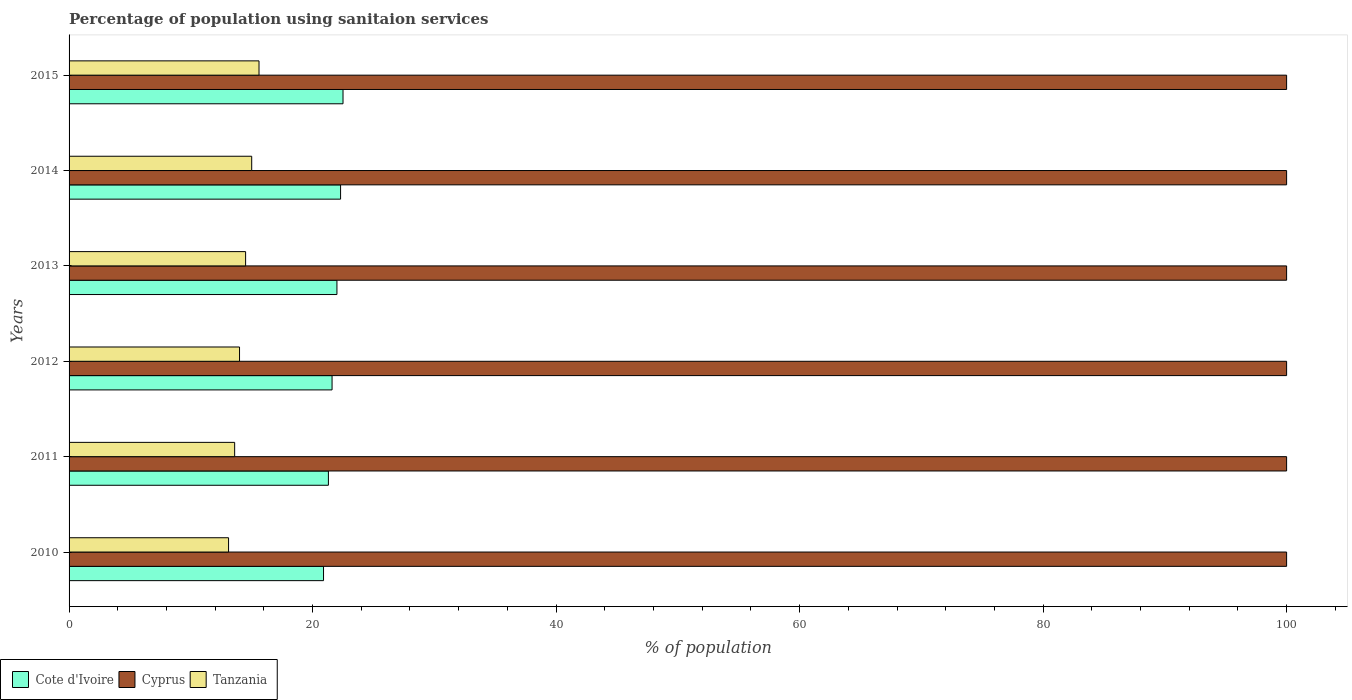How many bars are there on the 5th tick from the bottom?
Ensure brevity in your answer.  3. In how many cases, is the number of bars for a given year not equal to the number of legend labels?
Offer a very short reply. 0. What is the percentage of population using sanitaion services in Cyprus in 2010?
Give a very brief answer. 100. Across all years, what is the maximum percentage of population using sanitaion services in Cyprus?
Your response must be concise. 100. Across all years, what is the minimum percentage of population using sanitaion services in Cote d'Ivoire?
Offer a very short reply. 20.9. In which year was the percentage of population using sanitaion services in Tanzania minimum?
Make the answer very short. 2010. What is the total percentage of population using sanitaion services in Cote d'Ivoire in the graph?
Your response must be concise. 130.6. What is the difference between the percentage of population using sanitaion services in Tanzania in 2010 and that in 2013?
Offer a terse response. -1.4. What is the average percentage of population using sanitaion services in Cyprus per year?
Make the answer very short. 100. In the year 2015, what is the difference between the percentage of population using sanitaion services in Cyprus and percentage of population using sanitaion services in Cote d'Ivoire?
Give a very brief answer. 77.5. In how many years, is the percentage of population using sanitaion services in Tanzania greater than 72 %?
Your response must be concise. 0. What is the difference between the highest and the second highest percentage of population using sanitaion services in Cyprus?
Give a very brief answer. 0. What is the difference between the highest and the lowest percentage of population using sanitaion services in Cote d'Ivoire?
Ensure brevity in your answer.  1.6. What does the 1st bar from the top in 2015 represents?
Provide a short and direct response. Tanzania. What does the 2nd bar from the bottom in 2014 represents?
Provide a short and direct response. Cyprus. Is it the case that in every year, the sum of the percentage of population using sanitaion services in Cote d'Ivoire and percentage of population using sanitaion services in Tanzania is greater than the percentage of population using sanitaion services in Cyprus?
Keep it short and to the point. No. How many bars are there?
Provide a short and direct response. 18. Are all the bars in the graph horizontal?
Offer a very short reply. Yes. What is the difference between two consecutive major ticks on the X-axis?
Your answer should be compact. 20. What is the title of the graph?
Offer a terse response. Percentage of population using sanitaion services. Does "Guam" appear as one of the legend labels in the graph?
Provide a short and direct response. No. What is the label or title of the X-axis?
Provide a succinct answer. % of population. What is the label or title of the Y-axis?
Provide a short and direct response. Years. What is the % of population of Cote d'Ivoire in 2010?
Your response must be concise. 20.9. What is the % of population in Cyprus in 2010?
Your answer should be compact. 100. What is the % of population of Cote d'Ivoire in 2011?
Provide a succinct answer. 21.3. What is the % of population of Tanzania in 2011?
Give a very brief answer. 13.6. What is the % of population in Cote d'Ivoire in 2012?
Offer a very short reply. 21.6. What is the % of population of Cyprus in 2012?
Keep it short and to the point. 100. What is the % of population in Tanzania in 2012?
Ensure brevity in your answer.  14. What is the % of population of Cote d'Ivoire in 2013?
Provide a short and direct response. 22. What is the % of population of Cyprus in 2013?
Ensure brevity in your answer.  100. What is the % of population of Cote d'Ivoire in 2014?
Offer a terse response. 22.3. What is the % of population in Cyprus in 2014?
Your answer should be very brief. 100. What is the % of population in Cyprus in 2015?
Your answer should be compact. 100. Across all years, what is the maximum % of population of Cote d'Ivoire?
Give a very brief answer. 22.5. Across all years, what is the maximum % of population in Cyprus?
Give a very brief answer. 100. Across all years, what is the minimum % of population of Cote d'Ivoire?
Your answer should be very brief. 20.9. Across all years, what is the minimum % of population of Tanzania?
Give a very brief answer. 13.1. What is the total % of population in Cote d'Ivoire in the graph?
Your answer should be very brief. 130.6. What is the total % of population in Cyprus in the graph?
Give a very brief answer. 600. What is the total % of population of Tanzania in the graph?
Your response must be concise. 85.8. What is the difference between the % of population in Tanzania in 2010 and that in 2011?
Provide a short and direct response. -0.5. What is the difference between the % of population in Cyprus in 2010 and that in 2012?
Your response must be concise. 0. What is the difference between the % of population in Cote d'Ivoire in 2010 and that in 2013?
Your answer should be compact. -1.1. What is the difference between the % of population of Cyprus in 2010 and that in 2013?
Your response must be concise. 0. What is the difference between the % of population in Cyprus in 2010 and that in 2014?
Your answer should be compact. 0. What is the difference between the % of population in Cote d'Ivoire in 2010 and that in 2015?
Your answer should be compact. -1.6. What is the difference between the % of population in Cote d'Ivoire in 2012 and that in 2013?
Offer a very short reply. -0.4. What is the difference between the % of population in Cyprus in 2012 and that in 2013?
Give a very brief answer. 0. What is the difference between the % of population of Tanzania in 2012 and that in 2015?
Your response must be concise. -1.6. What is the difference between the % of population in Cyprus in 2013 and that in 2014?
Your answer should be compact. 0. What is the difference between the % of population of Tanzania in 2013 and that in 2015?
Keep it short and to the point. -1.1. What is the difference between the % of population of Cote d'Ivoire in 2014 and that in 2015?
Your response must be concise. -0.2. What is the difference between the % of population in Cyprus in 2014 and that in 2015?
Offer a terse response. 0. What is the difference between the % of population in Cote d'Ivoire in 2010 and the % of population in Cyprus in 2011?
Provide a short and direct response. -79.1. What is the difference between the % of population of Cyprus in 2010 and the % of population of Tanzania in 2011?
Keep it short and to the point. 86.4. What is the difference between the % of population of Cote d'Ivoire in 2010 and the % of population of Cyprus in 2012?
Provide a short and direct response. -79.1. What is the difference between the % of population of Cote d'Ivoire in 2010 and the % of population of Tanzania in 2012?
Ensure brevity in your answer.  6.9. What is the difference between the % of population of Cote d'Ivoire in 2010 and the % of population of Cyprus in 2013?
Make the answer very short. -79.1. What is the difference between the % of population in Cyprus in 2010 and the % of population in Tanzania in 2013?
Offer a very short reply. 85.5. What is the difference between the % of population of Cote d'Ivoire in 2010 and the % of population of Cyprus in 2014?
Provide a short and direct response. -79.1. What is the difference between the % of population in Cote d'Ivoire in 2010 and the % of population in Tanzania in 2014?
Make the answer very short. 5.9. What is the difference between the % of population of Cyprus in 2010 and the % of population of Tanzania in 2014?
Ensure brevity in your answer.  85. What is the difference between the % of population in Cote d'Ivoire in 2010 and the % of population in Cyprus in 2015?
Give a very brief answer. -79.1. What is the difference between the % of population in Cyprus in 2010 and the % of population in Tanzania in 2015?
Provide a short and direct response. 84.4. What is the difference between the % of population in Cote d'Ivoire in 2011 and the % of population in Cyprus in 2012?
Offer a very short reply. -78.7. What is the difference between the % of population of Cyprus in 2011 and the % of population of Tanzania in 2012?
Make the answer very short. 86. What is the difference between the % of population in Cote d'Ivoire in 2011 and the % of population in Cyprus in 2013?
Give a very brief answer. -78.7. What is the difference between the % of population of Cote d'Ivoire in 2011 and the % of population of Tanzania in 2013?
Provide a succinct answer. 6.8. What is the difference between the % of population of Cyprus in 2011 and the % of population of Tanzania in 2013?
Your response must be concise. 85.5. What is the difference between the % of population in Cote d'Ivoire in 2011 and the % of population in Cyprus in 2014?
Provide a short and direct response. -78.7. What is the difference between the % of population of Cyprus in 2011 and the % of population of Tanzania in 2014?
Provide a succinct answer. 85. What is the difference between the % of population of Cote d'Ivoire in 2011 and the % of population of Cyprus in 2015?
Your response must be concise. -78.7. What is the difference between the % of population in Cote d'Ivoire in 2011 and the % of population in Tanzania in 2015?
Your answer should be very brief. 5.7. What is the difference between the % of population of Cyprus in 2011 and the % of population of Tanzania in 2015?
Provide a short and direct response. 84.4. What is the difference between the % of population in Cote d'Ivoire in 2012 and the % of population in Cyprus in 2013?
Your answer should be very brief. -78.4. What is the difference between the % of population in Cote d'Ivoire in 2012 and the % of population in Tanzania in 2013?
Give a very brief answer. 7.1. What is the difference between the % of population of Cyprus in 2012 and the % of population of Tanzania in 2013?
Offer a terse response. 85.5. What is the difference between the % of population of Cote d'Ivoire in 2012 and the % of population of Cyprus in 2014?
Provide a succinct answer. -78.4. What is the difference between the % of population in Cote d'Ivoire in 2012 and the % of population in Tanzania in 2014?
Offer a very short reply. 6.6. What is the difference between the % of population in Cyprus in 2012 and the % of population in Tanzania in 2014?
Make the answer very short. 85. What is the difference between the % of population in Cote d'Ivoire in 2012 and the % of population in Cyprus in 2015?
Give a very brief answer. -78.4. What is the difference between the % of population in Cyprus in 2012 and the % of population in Tanzania in 2015?
Ensure brevity in your answer.  84.4. What is the difference between the % of population in Cote d'Ivoire in 2013 and the % of population in Cyprus in 2014?
Make the answer very short. -78. What is the difference between the % of population in Cote d'Ivoire in 2013 and the % of population in Tanzania in 2014?
Make the answer very short. 7. What is the difference between the % of population in Cyprus in 2013 and the % of population in Tanzania in 2014?
Your answer should be very brief. 85. What is the difference between the % of population in Cote d'Ivoire in 2013 and the % of population in Cyprus in 2015?
Keep it short and to the point. -78. What is the difference between the % of population in Cote d'Ivoire in 2013 and the % of population in Tanzania in 2015?
Offer a very short reply. 6.4. What is the difference between the % of population in Cyprus in 2013 and the % of population in Tanzania in 2015?
Give a very brief answer. 84.4. What is the difference between the % of population of Cote d'Ivoire in 2014 and the % of population of Cyprus in 2015?
Make the answer very short. -77.7. What is the difference between the % of population of Cote d'Ivoire in 2014 and the % of population of Tanzania in 2015?
Offer a terse response. 6.7. What is the difference between the % of population of Cyprus in 2014 and the % of population of Tanzania in 2015?
Your answer should be compact. 84.4. What is the average % of population in Cote d'Ivoire per year?
Provide a short and direct response. 21.77. What is the average % of population of Tanzania per year?
Your answer should be very brief. 14.3. In the year 2010, what is the difference between the % of population in Cote d'Ivoire and % of population in Cyprus?
Make the answer very short. -79.1. In the year 2010, what is the difference between the % of population of Cote d'Ivoire and % of population of Tanzania?
Offer a very short reply. 7.8. In the year 2010, what is the difference between the % of population in Cyprus and % of population in Tanzania?
Give a very brief answer. 86.9. In the year 2011, what is the difference between the % of population of Cote d'Ivoire and % of population of Cyprus?
Ensure brevity in your answer.  -78.7. In the year 2011, what is the difference between the % of population in Cote d'Ivoire and % of population in Tanzania?
Ensure brevity in your answer.  7.7. In the year 2011, what is the difference between the % of population in Cyprus and % of population in Tanzania?
Provide a short and direct response. 86.4. In the year 2012, what is the difference between the % of population in Cote d'Ivoire and % of population in Cyprus?
Make the answer very short. -78.4. In the year 2012, what is the difference between the % of population in Cyprus and % of population in Tanzania?
Provide a succinct answer. 86. In the year 2013, what is the difference between the % of population in Cote d'Ivoire and % of population in Cyprus?
Your response must be concise. -78. In the year 2013, what is the difference between the % of population of Cote d'Ivoire and % of population of Tanzania?
Offer a very short reply. 7.5. In the year 2013, what is the difference between the % of population of Cyprus and % of population of Tanzania?
Offer a very short reply. 85.5. In the year 2014, what is the difference between the % of population in Cote d'Ivoire and % of population in Cyprus?
Keep it short and to the point. -77.7. In the year 2014, what is the difference between the % of population in Cyprus and % of population in Tanzania?
Offer a very short reply. 85. In the year 2015, what is the difference between the % of population of Cote d'Ivoire and % of population of Cyprus?
Your answer should be compact. -77.5. In the year 2015, what is the difference between the % of population of Cote d'Ivoire and % of population of Tanzania?
Provide a short and direct response. 6.9. In the year 2015, what is the difference between the % of population of Cyprus and % of population of Tanzania?
Give a very brief answer. 84.4. What is the ratio of the % of population of Cote d'Ivoire in 2010 to that in 2011?
Your answer should be compact. 0.98. What is the ratio of the % of population of Cyprus in 2010 to that in 2011?
Your answer should be compact. 1. What is the ratio of the % of population in Tanzania in 2010 to that in 2011?
Your answer should be very brief. 0.96. What is the ratio of the % of population of Cote d'Ivoire in 2010 to that in 2012?
Keep it short and to the point. 0.97. What is the ratio of the % of population of Cyprus in 2010 to that in 2012?
Keep it short and to the point. 1. What is the ratio of the % of population in Tanzania in 2010 to that in 2012?
Your response must be concise. 0.94. What is the ratio of the % of population of Cote d'Ivoire in 2010 to that in 2013?
Make the answer very short. 0.95. What is the ratio of the % of population in Tanzania in 2010 to that in 2013?
Your response must be concise. 0.9. What is the ratio of the % of population of Cote d'Ivoire in 2010 to that in 2014?
Make the answer very short. 0.94. What is the ratio of the % of population in Tanzania in 2010 to that in 2014?
Provide a short and direct response. 0.87. What is the ratio of the % of population of Cote d'Ivoire in 2010 to that in 2015?
Keep it short and to the point. 0.93. What is the ratio of the % of population in Tanzania in 2010 to that in 2015?
Your answer should be compact. 0.84. What is the ratio of the % of population of Cote d'Ivoire in 2011 to that in 2012?
Give a very brief answer. 0.99. What is the ratio of the % of population of Tanzania in 2011 to that in 2012?
Give a very brief answer. 0.97. What is the ratio of the % of population in Cote d'Ivoire in 2011 to that in 2013?
Your answer should be very brief. 0.97. What is the ratio of the % of population in Tanzania in 2011 to that in 2013?
Keep it short and to the point. 0.94. What is the ratio of the % of population in Cote d'Ivoire in 2011 to that in 2014?
Offer a very short reply. 0.96. What is the ratio of the % of population of Cyprus in 2011 to that in 2014?
Ensure brevity in your answer.  1. What is the ratio of the % of population in Tanzania in 2011 to that in 2014?
Make the answer very short. 0.91. What is the ratio of the % of population in Cote d'Ivoire in 2011 to that in 2015?
Ensure brevity in your answer.  0.95. What is the ratio of the % of population of Tanzania in 2011 to that in 2015?
Your answer should be compact. 0.87. What is the ratio of the % of population of Cote d'Ivoire in 2012 to that in 2013?
Make the answer very short. 0.98. What is the ratio of the % of population of Cyprus in 2012 to that in 2013?
Your answer should be very brief. 1. What is the ratio of the % of population in Tanzania in 2012 to that in 2013?
Keep it short and to the point. 0.97. What is the ratio of the % of population in Cote d'Ivoire in 2012 to that in 2014?
Your answer should be very brief. 0.97. What is the ratio of the % of population in Cote d'Ivoire in 2012 to that in 2015?
Keep it short and to the point. 0.96. What is the ratio of the % of population in Tanzania in 2012 to that in 2015?
Ensure brevity in your answer.  0.9. What is the ratio of the % of population in Cote d'Ivoire in 2013 to that in 2014?
Offer a terse response. 0.99. What is the ratio of the % of population in Tanzania in 2013 to that in 2014?
Offer a very short reply. 0.97. What is the ratio of the % of population of Cote d'Ivoire in 2013 to that in 2015?
Offer a terse response. 0.98. What is the ratio of the % of population of Cyprus in 2013 to that in 2015?
Your answer should be compact. 1. What is the ratio of the % of population in Tanzania in 2013 to that in 2015?
Your answer should be compact. 0.93. What is the ratio of the % of population in Cote d'Ivoire in 2014 to that in 2015?
Your answer should be very brief. 0.99. What is the ratio of the % of population of Tanzania in 2014 to that in 2015?
Your answer should be very brief. 0.96. What is the difference between the highest and the lowest % of population of Cote d'Ivoire?
Provide a succinct answer. 1.6. What is the difference between the highest and the lowest % of population of Tanzania?
Make the answer very short. 2.5. 